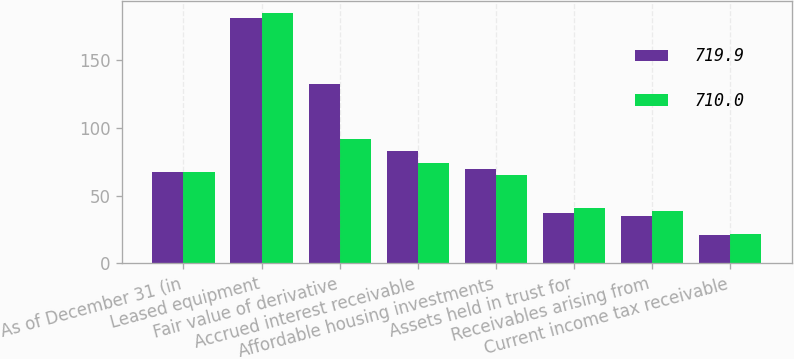Convert chart. <chart><loc_0><loc_0><loc_500><loc_500><stacked_bar_chart><ecel><fcel>As of December 31 (in<fcel>Leased equipment<fcel>Fair value of derivative<fcel>Accrued interest receivable<fcel>Affordable housing investments<fcel>Assets held in trust for<fcel>Receivables arising from<fcel>Current income tax receivable<nl><fcel>719.9<fcel>67.3<fcel>180.9<fcel>132.4<fcel>82.6<fcel>69.6<fcel>37.1<fcel>34.8<fcel>21.1<nl><fcel>710<fcel>67.3<fcel>184.3<fcel>91.9<fcel>74.3<fcel>65<fcel>40.7<fcel>38.4<fcel>21.6<nl></chart> 